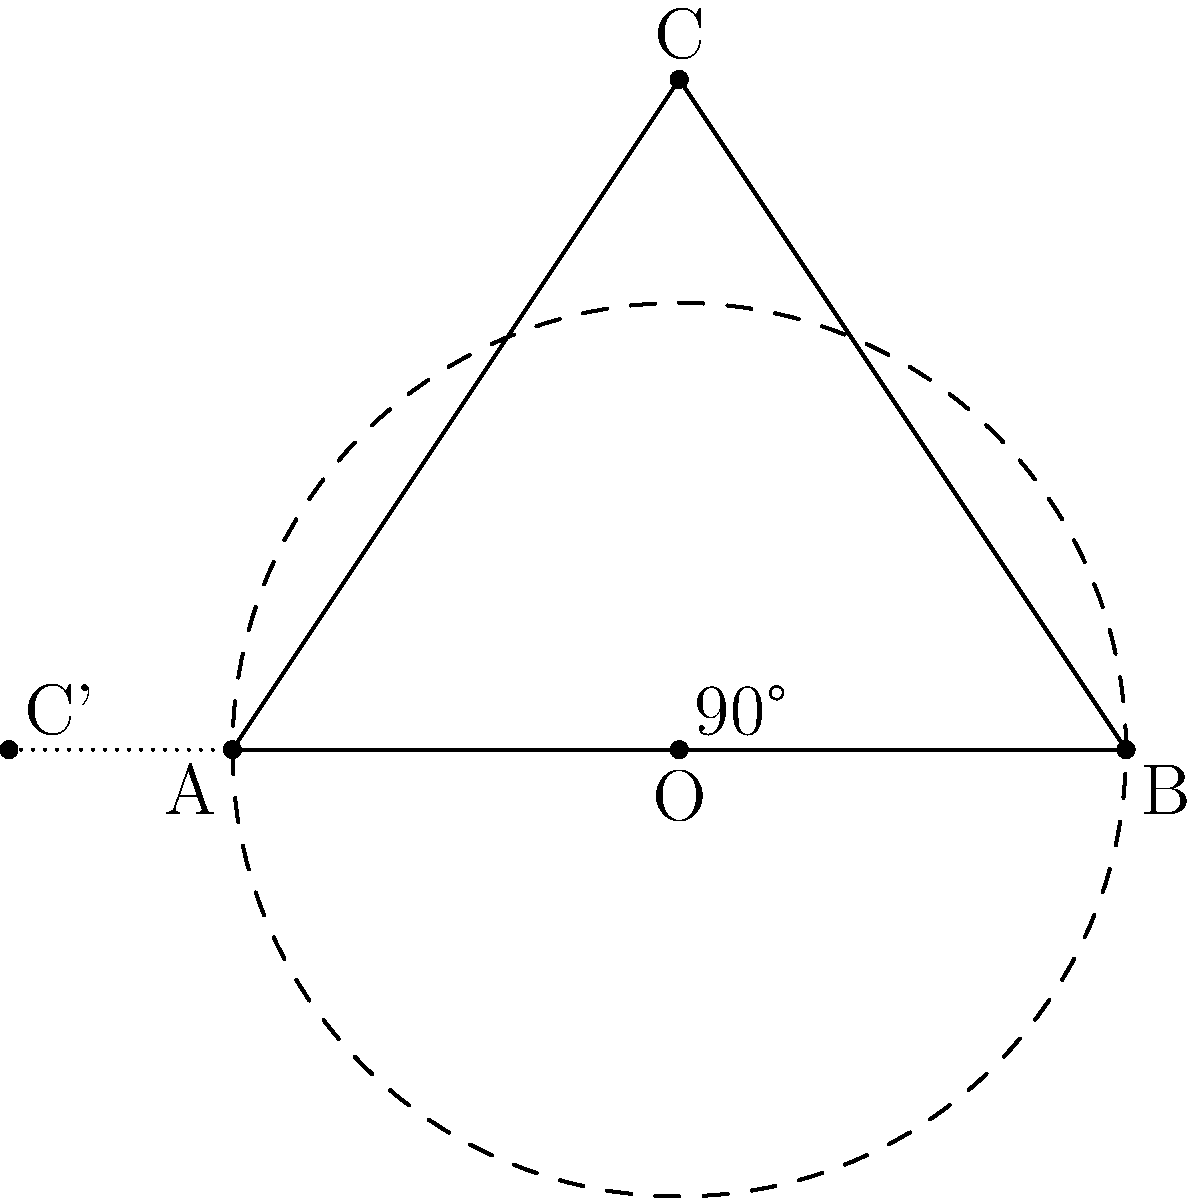In the figure above, triangle ABC is rotated 90° counterclockwise around point O. What are the coordinates of point C after the rotation? To solve this problem, we'll follow these steps:

1. Identify the center of rotation (O) and its coordinates:
   O is at (2,0)

2. Identify the original coordinates of point C:
   C is at (2,3)

3. To rotate a point (x,y) by 90° counterclockwise around the origin (0,0), we use the formula:
   $$(x',y') = (-y,x)$$

4. However, our center of rotation is not at the origin. So we need to:
   a) Translate the point to make O the origin
   b) Rotate the point
   c) Translate the point back

5. Translating C to make O the origin:
   (2,3) - (2,0) = (0,3)

6. Rotating (0,3) by 90° counterclockwise:
   $(-3,0)$

7. Translating back:
   $(-3,0) + (2,0) = (-1,0)$

Therefore, after rotation, point C' will be at coordinates (-1,0).
Answer: (-1,0) 